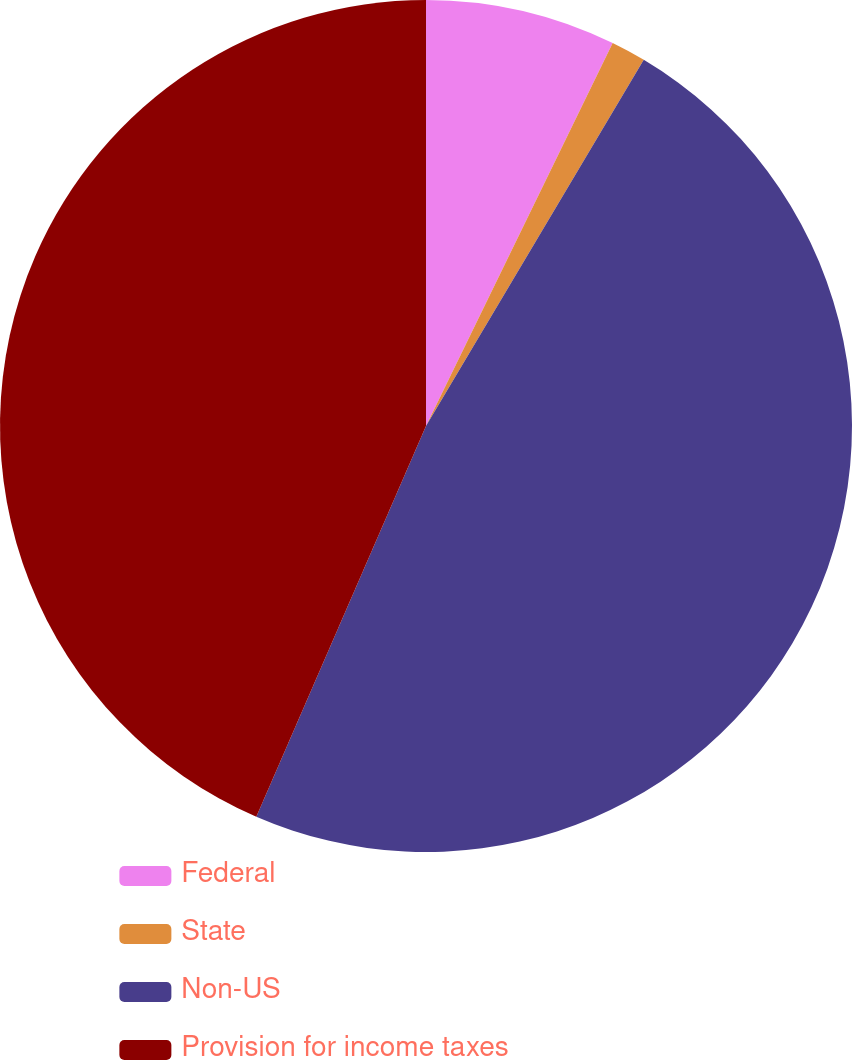Convert chart to OTSL. <chart><loc_0><loc_0><loc_500><loc_500><pie_chart><fcel>Federal<fcel>State<fcel>Non-US<fcel>Provision for income taxes<nl><fcel>7.22%<fcel>1.32%<fcel>47.98%<fcel>43.48%<nl></chart> 